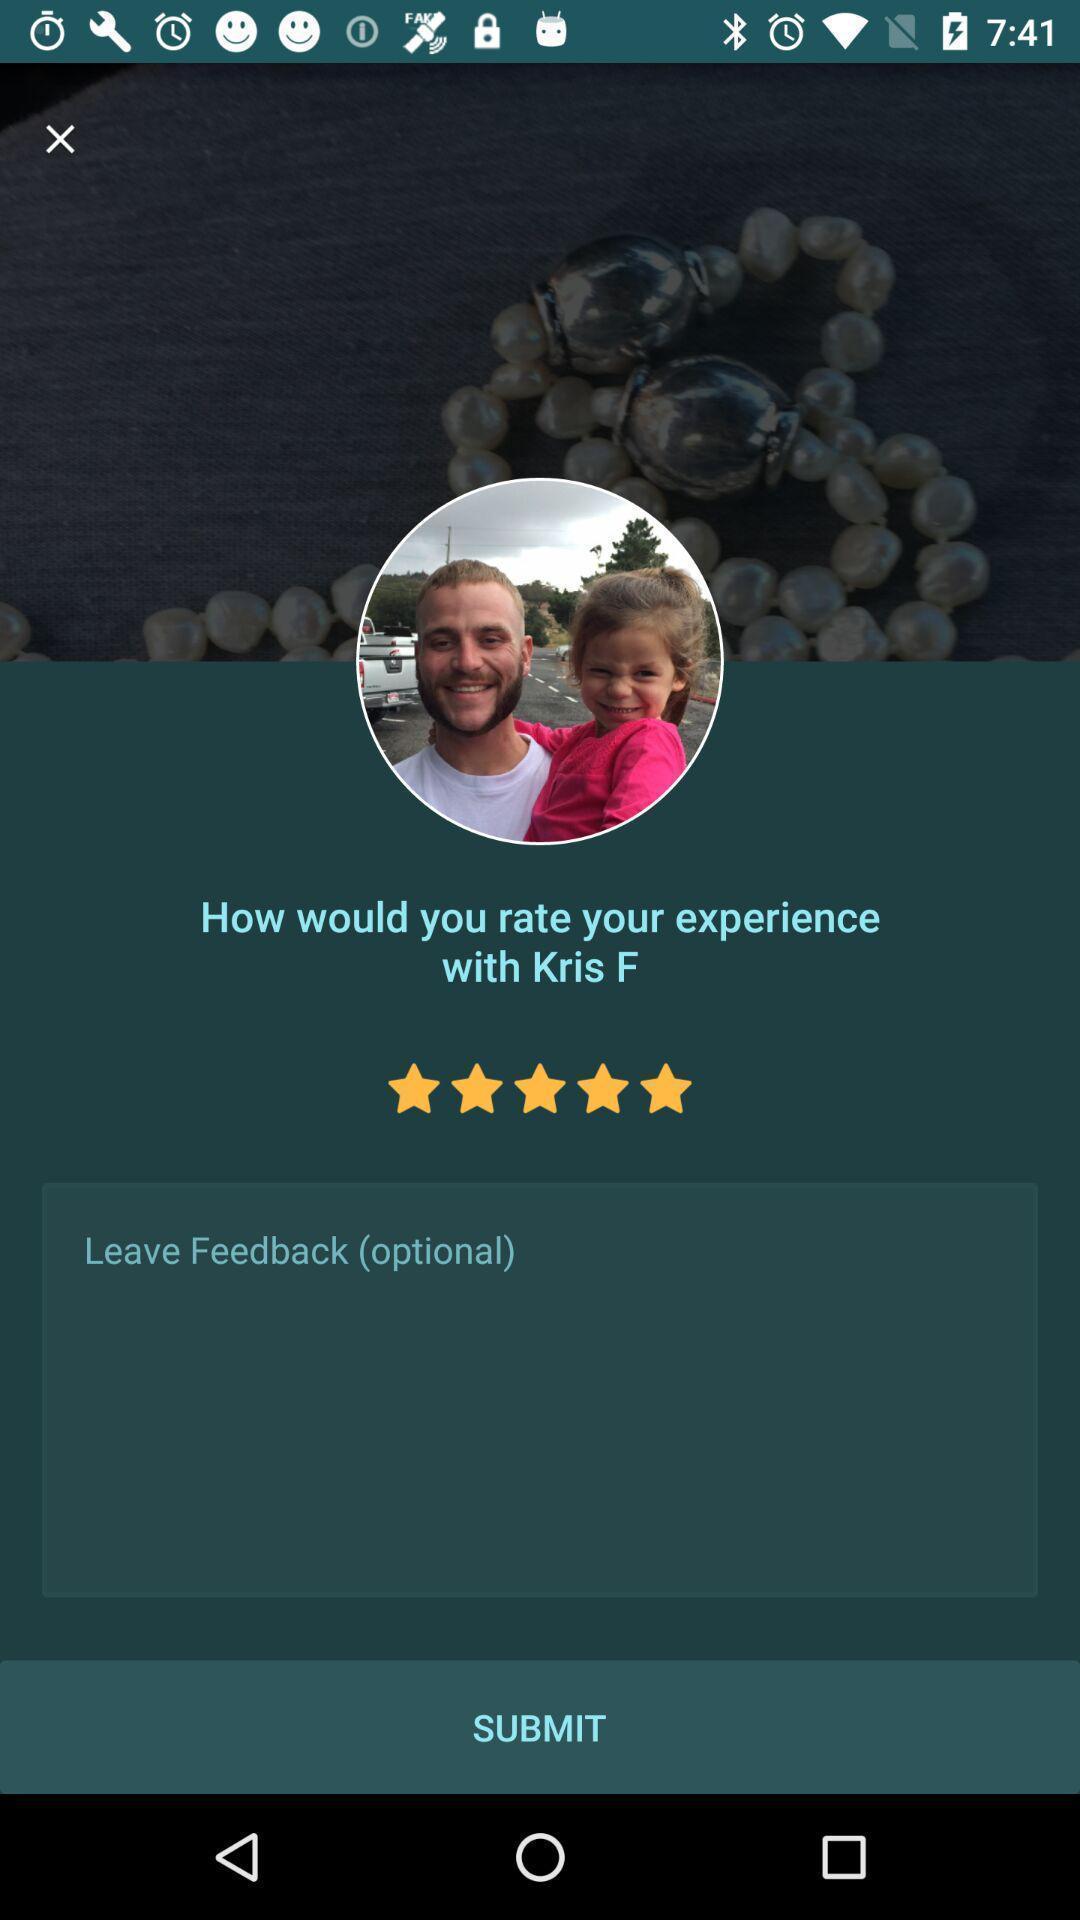Give me a narrative description of this picture. Submit page. 